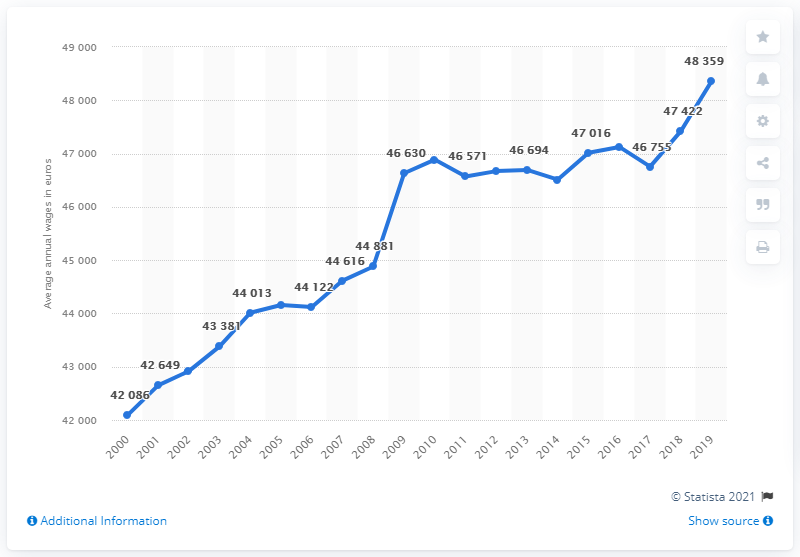Highlight a few significant elements in this photo. From 2000 to 2019, the average annual wage in the Netherlands was 48,359 euros. 